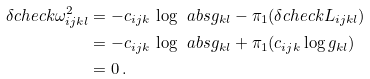Convert formula to latex. <formula><loc_0><loc_0><loc_500><loc_500>\delta c h e c k \omega ^ { 2 } _ { i j k l } & = - c _ { i j k } \, \log \, \ a b s { g _ { k l } } - \pi _ { 1 } ( \delta c h e c k L _ { i j k l } ) \\ & = - c _ { i j k } \, \log \, \ a b s { g _ { k l } } + \pi _ { 1 } ( c _ { i j k } \log g _ { k l } ) \\ & = 0 \, .</formula> 